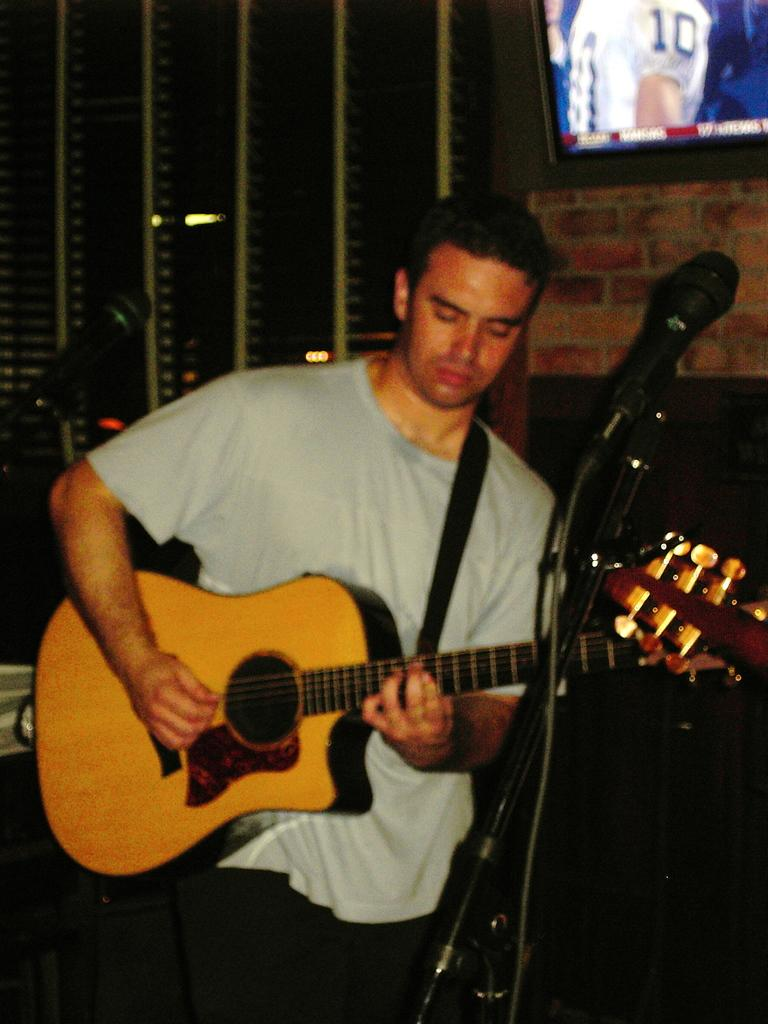What is the main subject of the image? The main subject of the image is a man. What is the man doing in the image? The man is standing and playing a guitar. What object is in front of the man? There is a microphone in front of the man. What can be seen on the wall behind the man? There is a TV on the wall behind the man. What type of amusement can be seen in the park in the image? There is no park or amusement present in the image; it features a man playing a guitar with a microphone and a TV on the wall behind him. 